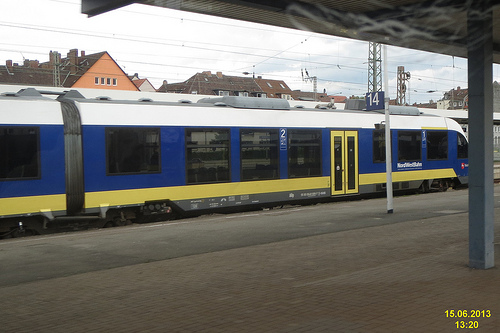Can you tell me more about the train's design and its features? The train features a sleek modern design, with a blue and yellow livery. It has numerous windows running along its length, which suggests it's designed for passenger service rather than freight, and it’s a bi-level train, offering more seating capacity. 